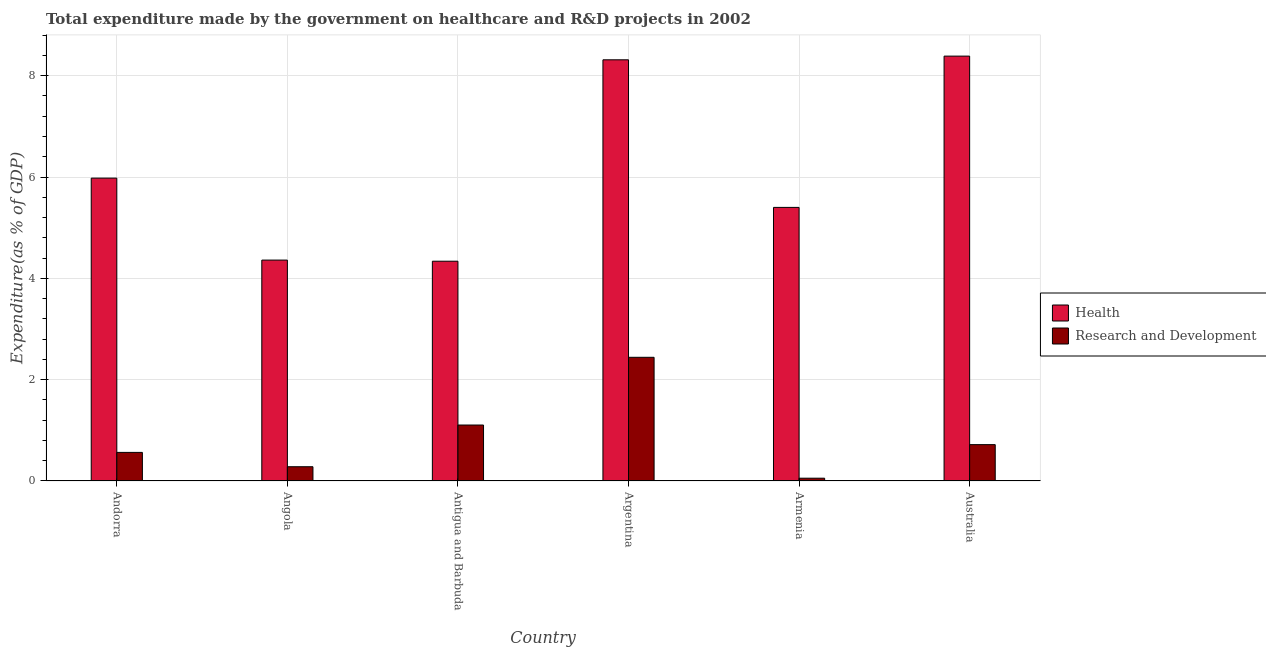Are the number of bars per tick equal to the number of legend labels?
Provide a succinct answer. Yes. How many bars are there on the 1st tick from the right?
Your answer should be compact. 2. What is the expenditure in r&d in Australia?
Offer a terse response. 0.72. Across all countries, what is the maximum expenditure in healthcare?
Offer a very short reply. 8.39. Across all countries, what is the minimum expenditure in r&d?
Keep it short and to the point. 0.06. In which country was the expenditure in r&d minimum?
Provide a succinct answer. Armenia. What is the total expenditure in r&d in the graph?
Your answer should be very brief. 5.17. What is the difference between the expenditure in r&d in Argentina and that in Australia?
Your answer should be compact. 1.72. What is the difference between the expenditure in r&d in Antigua and Barbuda and the expenditure in healthcare in Andorra?
Offer a terse response. -4.87. What is the average expenditure in healthcare per country?
Give a very brief answer. 6.13. What is the difference between the expenditure in healthcare and expenditure in r&d in Angola?
Provide a succinct answer. 4.08. What is the ratio of the expenditure in healthcare in Armenia to that in Australia?
Your answer should be compact. 0.64. Is the expenditure in r&d in Angola less than that in Australia?
Provide a succinct answer. Yes. Is the difference between the expenditure in r&d in Antigua and Barbuda and Armenia greater than the difference between the expenditure in healthcare in Antigua and Barbuda and Armenia?
Provide a succinct answer. Yes. What is the difference between the highest and the second highest expenditure in healthcare?
Provide a succinct answer. 0.07. What is the difference between the highest and the lowest expenditure in healthcare?
Your response must be concise. 4.05. Is the sum of the expenditure in healthcare in Antigua and Barbuda and Australia greater than the maximum expenditure in r&d across all countries?
Your answer should be very brief. Yes. What does the 1st bar from the left in Argentina represents?
Provide a short and direct response. Health. What does the 1st bar from the right in Argentina represents?
Your answer should be very brief. Research and Development. How many bars are there?
Ensure brevity in your answer.  12. How many countries are there in the graph?
Your answer should be compact. 6. Are the values on the major ticks of Y-axis written in scientific E-notation?
Your answer should be compact. No. Does the graph contain any zero values?
Your answer should be very brief. No. Does the graph contain grids?
Provide a succinct answer. Yes. Where does the legend appear in the graph?
Your answer should be compact. Center right. How many legend labels are there?
Keep it short and to the point. 2. How are the legend labels stacked?
Your answer should be very brief. Vertical. What is the title of the graph?
Provide a short and direct response. Total expenditure made by the government on healthcare and R&D projects in 2002. Does "Resident" appear as one of the legend labels in the graph?
Give a very brief answer. No. What is the label or title of the Y-axis?
Offer a very short reply. Expenditure(as % of GDP). What is the Expenditure(as % of GDP) in Health in Andorra?
Ensure brevity in your answer.  5.98. What is the Expenditure(as % of GDP) of Research and Development in Andorra?
Provide a short and direct response. 0.56. What is the Expenditure(as % of GDP) in Health in Angola?
Offer a terse response. 4.36. What is the Expenditure(as % of GDP) in Research and Development in Angola?
Your answer should be very brief. 0.28. What is the Expenditure(as % of GDP) in Health in Antigua and Barbuda?
Your answer should be very brief. 4.34. What is the Expenditure(as % of GDP) in Research and Development in Antigua and Barbuda?
Offer a terse response. 1.1. What is the Expenditure(as % of GDP) of Health in Argentina?
Ensure brevity in your answer.  8.31. What is the Expenditure(as % of GDP) in Research and Development in Argentina?
Make the answer very short. 2.44. What is the Expenditure(as % of GDP) of Health in Armenia?
Make the answer very short. 5.4. What is the Expenditure(as % of GDP) in Research and Development in Armenia?
Your answer should be very brief. 0.06. What is the Expenditure(as % of GDP) of Health in Australia?
Keep it short and to the point. 8.39. What is the Expenditure(as % of GDP) of Research and Development in Australia?
Provide a succinct answer. 0.72. Across all countries, what is the maximum Expenditure(as % of GDP) of Health?
Keep it short and to the point. 8.39. Across all countries, what is the maximum Expenditure(as % of GDP) of Research and Development?
Give a very brief answer. 2.44. Across all countries, what is the minimum Expenditure(as % of GDP) in Health?
Provide a short and direct response. 4.34. Across all countries, what is the minimum Expenditure(as % of GDP) in Research and Development?
Ensure brevity in your answer.  0.06. What is the total Expenditure(as % of GDP) of Health in the graph?
Provide a succinct answer. 36.78. What is the total Expenditure(as % of GDP) of Research and Development in the graph?
Your response must be concise. 5.17. What is the difference between the Expenditure(as % of GDP) of Health in Andorra and that in Angola?
Give a very brief answer. 1.62. What is the difference between the Expenditure(as % of GDP) in Research and Development in Andorra and that in Angola?
Make the answer very short. 0.28. What is the difference between the Expenditure(as % of GDP) of Health in Andorra and that in Antigua and Barbuda?
Provide a succinct answer. 1.64. What is the difference between the Expenditure(as % of GDP) of Research and Development in Andorra and that in Antigua and Barbuda?
Provide a short and direct response. -0.54. What is the difference between the Expenditure(as % of GDP) in Health in Andorra and that in Argentina?
Your response must be concise. -2.34. What is the difference between the Expenditure(as % of GDP) of Research and Development in Andorra and that in Argentina?
Offer a very short reply. -1.88. What is the difference between the Expenditure(as % of GDP) of Health in Andorra and that in Armenia?
Offer a terse response. 0.58. What is the difference between the Expenditure(as % of GDP) in Research and Development in Andorra and that in Armenia?
Your answer should be compact. 0.51. What is the difference between the Expenditure(as % of GDP) in Health in Andorra and that in Australia?
Offer a terse response. -2.41. What is the difference between the Expenditure(as % of GDP) in Research and Development in Andorra and that in Australia?
Your response must be concise. -0.15. What is the difference between the Expenditure(as % of GDP) of Health in Angola and that in Antigua and Barbuda?
Offer a terse response. 0.02. What is the difference between the Expenditure(as % of GDP) in Research and Development in Angola and that in Antigua and Barbuda?
Your answer should be compact. -0.82. What is the difference between the Expenditure(as % of GDP) of Health in Angola and that in Argentina?
Keep it short and to the point. -3.95. What is the difference between the Expenditure(as % of GDP) in Research and Development in Angola and that in Argentina?
Make the answer very short. -2.16. What is the difference between the Expenditure(as % of GDP) of Health in Angola and that in Armenia?
Your response must be concise. -1.04. What is the difference between the Expenditure(as % of GDP) of Research and Development in Angola and that in Armenia?
Provide a short and direct response. 0.23. What is the difference between the Expenditure(as % of GDP) of Health in Angola and that in Australia?
Your answer should be very brief. -4.03. What is the difference between the Expenditure(as % of GDP) in Research and Development in Angola and that in Australia?
Provide a succinct answer. -0.44. What is the difference between the Expenditure(as % of GDP) of Health in Antigua and Barbuda and that in Argentina?
Provide a succinct answer. -3.98. What is the difference between the Expenditure(as % of GDP) in Research and Development in Antigua and Barbuda and that in Argentina?
Your answer should be compact. -1.34. What is the difference between the Expenditure(as % of GDP) of Health in Antigua and Barbuda and that in Armenia?
Make the answer very short. -1.06. What is the difference between the Expenditure(as % of GDP) of Research and Development in Antigua and Barbuda and that in Armenia?
Your answer should be compact. 1.05. What is the difference between the Expenditure(as % of GDP) of Health in Antigua and Barbuda and that in Australia?
Provide a short and direct response. -4.05. What is the difference between the Expenditure(as % of GDP) in Research and Development in Antigua and Barbuda and that in Australia?
Provide a short and direct response. 0.39. What is the difference between the Expenditure(as % of GDP) in Health in Argentina and that in Armenia?
Ensure brevity in your answer.  2.91. What is the difference between the Expenditure(as % of GDP) in Research and Development in Argentina and that in Armenia?
Keep it short and to the point. 2.39. What is the difference between the Expenditure(as % of GDP) of Health in Argentina and that in Australia?
Your answer should be compact. -0.07. What is the difference between the Expenditure(as % of GDP) in Research and Development in Argentina and that in Australia?
Offer a terse response. 1.72. What is the difference between the Expenditure(as % of GDP) in Health in Armenia and that in Australia?
Keep it short and to the point. -2.99. What is the difference between the Expenditure(as % of GDP) of Research and Development in Armenia and that in Australia?
Your response must be concise. -0.66. What is the difference between the Expenditure(as % of GDP) of Health in Andorra and the Expenditure(as % of GDP) of Research and Development in Angola?
Your answer should be compact. 5.7. What is the difference between the Expenditure(as % of GDP) in Health in Andorra and the Expenditure(as % of GDP) in Research and Development in Antigua and Barbuda?
Your answer should be very brief. 4.87. What is the difference between the Expenditure(as % of GDP) of Health in Andorra and the Expenditure(as % of GDP) of Research and Development in Argentina?
Ensure brevity in your answer.  3.54. What is the difference between the Expenditure(as % of GDP) of Health in Andorra and the Expenditure(as % of GDP) of Research and Development in Armenia?
Provide a short and direct response. 5.92. What is the difference between the Expenditure(as % of GDP) of Health in Andorra and the Expenditure(as % of GDP) of Research and Development in Australia?
Offer a very short reply. 5.26. What is the difference between the Expenditure(as % of GDP) in Health in Angola and the Expenditure(as % of GDP) in Research and Development in Antigua and Barbuda?
Your response must be concise. 3.26. What is the difference between the Expenditure(as % of GDP) in Health in Angola and the Expenditure(as % of GDP) in Research and Development in Argentina?
Make the answer very short. 1.92. What is the difference between the Expenditure(as % of GDP) in Health in Angola and the Expenditure(as % of GDP) in Research and Development in Armenia?
Offer a very short reply. 4.31. What is the difference between the Expenditure(as % of GDP) of Health in Angola and the Expenditure(as % of GDP) of Research and Development in Australia?
Keep it short and to the point. 3.64. What is the difference between the Expenditure(as % of GDP) in Health in Antigua and Barbuda and the Expenditure(as % of GDP) in Research and Development in Argentina?
Your response must be concise. 1.9. What is the difference between the Expenditure(as % of GDP) of Health in Antigua and Barbuda and the Expenditure(as % of GDP) of Research and Development in Armenia?
Offer a terse response. 4.28. What is the difference between the Expenditure(as % of GDP) in Health in Antigua and Barbuda and the Expenditure(as % of GDP) in Research and Development in Australia?
Provide a succinct answer. 3.62. What is the difference between the Expenditure(as % of GDP) of Health in Argentina and the Expenditure(as % of GDP) of Research and Development in Armenia?
Keep it short and to the point. 8.26. What is the difference between the Expenditure(as % of GDP) of Health in Argentina and the Expenditure(as % of GDP) of Research and Development in Australia?
Make the answer very short. 7.6. What is the difference between the Expenditure(as % of GDP) of Health in Armenia and the Expenditure(as % of GDP) of Research and Development in Australia?
Keep it short and to the point. 4.68. What is the average Expenditure(as % of GDP) of Health per country?
Make the answer very short. 6.13. What is the average Expenditure(as % of GDP) of Research and Development per country?
Give a very brief answer. 0.86. What is the difference between the Expenditure(as % of GDP) of Health and Expenditure(as % of GDP) of Research and Development in Andorra?
Your answer should be very brief. 5.41. What is the difference between the Expenditure(as % of GDP) of Health and Expenditure(as % of GDP) of Research and Development in Angola?
Your answer should be very brief. 4.08. What is the difference between the Expenditure(as % of GDP) in Health and Expenditure(as % of GDP) in Research and Development in Antigua and Barbuda?
Offer a very short reply. 3.23. What is the difference between the Expenditure(as % of GDP) in Health and Expenditure(as % of GDP) in Research and Development in Argentina?
Your answer should be compact. 5.87. What is the difference between the Expenditure(as % of GDP) of Health and Expenditure(as % of GDP) of Research and Development in Armenia?
Provide a succinct answer. 5.35. What is the difference between the Expenditure(as % of GDP) in Health and Expenditure(as % of GDP) in Research and Development in Australia?
Provide a succinct answer. 7.67. What is the ratio of the Expenditure(as % of GDP) in Health in Andorra to that in Angola?
Make the answer very short. 1.37. What is the ratio of the Expenditure(as % of GDP) in Research and Development in Andorra to that in Angola?
Your answer should be compact. 2.01. What is the ratio of the Expenditure(as % of GDP) in Health in Andorra to that in Antigua and Barbuda?
Your answer should be very brief. 1.38. What is the ratio of the Expenditure(as % of GDP) in Research and Development in Andorra to that in Antigua and Barbuda?
Provide a short and direct response. 0.51. What is the ratio of the Expenditure(as % of GDP) of Health in Andorra to that in Argentina?
Give a very brief answer. 0.72. What is the ratio of the Expenditure(as % of GDP) in Research and Development in Andorra to that in Argentina?
Your answer should be very brief. 0.23. What is the ratio of the Expenditure(as % of GDP) of Health in Andorra to that in Armenia?
Provide a short and direct response. 1.11. What is the ratio of the Expenditure(as % of GDP) in Research and Development in Andorra to that in Armenia?
Keep it short and to the point. 10.2. What is the ratio of the Expenditure(as % of GDP) in Health in Andorra to that in Australia?
Your answer should be very brief. 0.71. What is the ratio of the Expenditure(as % of GDP) of Research and Development in Andorra to that in Australia?
Provide a succinct answer. 0.79. What is the ratio of the Expenditure(as % of GDP) in Health in Angola to that in Antigua and Barbuda?
Give a very brief answer. 1.01. What is the ratio of the Expenditure(as % of GDP) in Research and Development in Angola to that in Antigua and Barbuda?
Offer a terse response. 0.25. What is the ratio of the Expenditure(as % of GDP) of Health in Angola to that in Argentina?
Provide a short and direct response. 0.52. What is the ratio of the Expenditure(as % of GDP) of Research and Development in Angola to that in Argentina?
Offer a very short reply. 0.12. What is the ratio of the Expenditure(as % of GDP) in Health in Angola to that in Armenia?
Provide a short and direct response. 0.81. What is the ratio of the Expenditure(as % of GDP) of Research and Development in Angola to that in Armenia?
Ensure brevity in your answer.  5.09. What is the ratio of the Expenditure(as % of GDP) in Health in Angola to that in Australia?
Provide a short and direct response. 0.52. What is the ratio of the Expenditure(as % of GDP) in Research and Development in Angola to that in Australia?
Offer a very short reply. 0.39. What is the ratio of the Expenditure(as % of GDP) of Health in Antigua and Barbuda to that in Argentina?
Provide a short and direct response. 0.52. What is the ratio of the Expenditure(as % of GDP) of Research and Development in Antigua and Barbuda to that in Argentina?
Provide a short and direct response. 0.45. What is the ratio of the Expenditure(as % of GDP) of Health in Antigua and Barbuda to that in Armenia?
Keep it short and to the point. 0.8. What is the ratio of the Expenditure(as % of GDP) in Research and Development in Antigua and Barbuda to that in Armenia?
Ensure brevity in your answer.  19.97. What is the ratio of the Expenditure(as % of GDP) in Health in Antigua and Barbuda to that in Australia?
Provide a succinct answer. 0.52. What is the ratio of the Expenditure(as % of GDP) in Research and Development in Antigua and Barbuda to that in Australia?
Your answer should be compact. 1.54. What is the ratio of the Expenditure(as % of GDP) of Health in Argentina to that in Armenia?
Offer a terse response. 1.54. What is the ratio of the Expenditure(as % of GDP) of Research and Development in Argentina to that in Armenia?
Give a very brief answer. 44.12. What is the ratio of the Expenditure(as % of GDP) of Health in Argentina to that in Australia?
Your answer should be compact. 0.99. What is the ratio of the Expenditure(as % of GDP) of Research and Development in Argentina to that in Australia?
Make the answer very short. 3.4. What is the ratio of the Expenditure(as % of GDP) in Health in Armenia to that in Australia?
Provide a succinct answer. 0.64. What is the ratio of the Expenditure(as % of GDP) in Research and Development in Armenia to that in Australia?
Make the answer very short. 0.08. What is the difference between the highest and the second highest Expenditure(as % of GDP) in Health?
Provide a short and direct response. 0.07. What is the difference between the highest and the second highest Expenditure(as % of GDP) of Research and Development?
Offer a terse response. 1.34. What is the difference between the highest and the lowest Expenditure(as % of GDP) in Health?
Offer a very short reply. 4.05. What is the difference between the highest and the lowest Expenditure(as % of GDP) in Research and Development?
Your answer should be very brief. 2.39. 